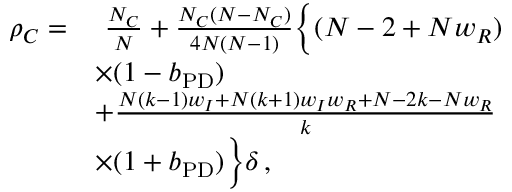Convert formula to latex. <formula><loc_0><loc_0><loc_500><loc_500>\begin{array} { r l } { \rho _ { C } = } & { \frac { N _ { C } } { N } + \frac { N _ { C } ( N - N _ { C } ) } { 4 N ( N - 1 ) } \left \{ ( N - 2 + N w _ { R } ) } \\ & { \times ( 1 - b _ { P D } ) } \\ & { + \frac { N ( k - 1 ) w _ { I } + N ( k + 1 ) w _ { I } w _ { R } + N - 2 k - N w _ { R } } { k } } \\ & { \times ( 1 + b _ { P D } ) \right \} \delta \, , } \end{array}</formula> 